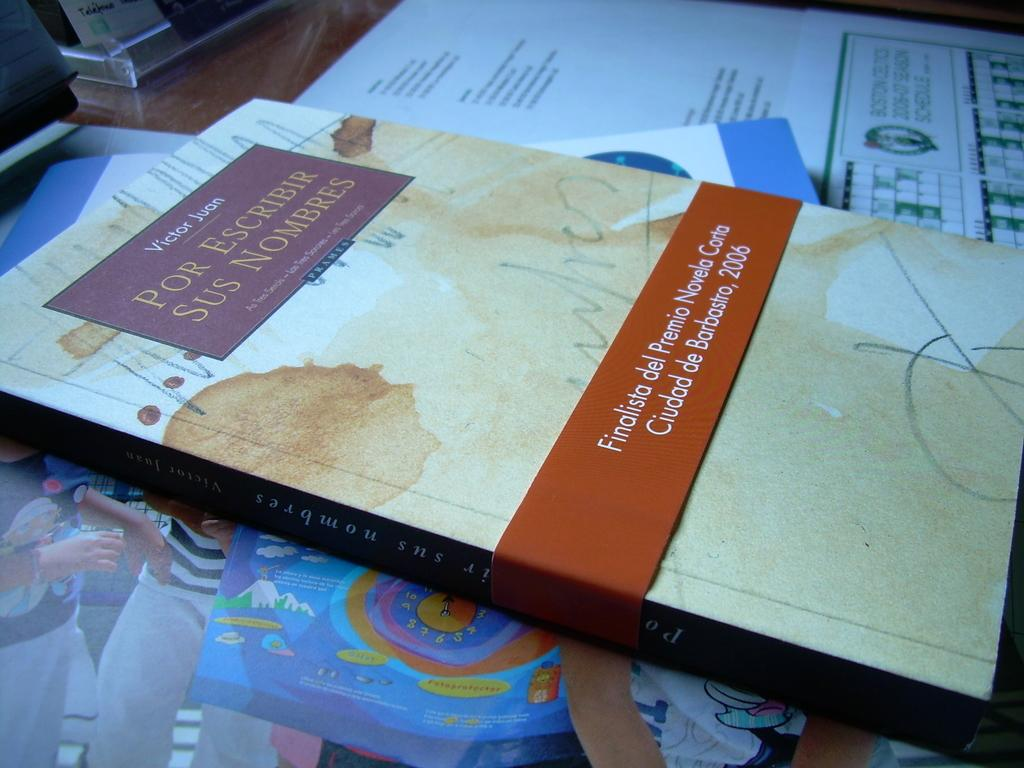<image>
Provide a brief description of the given image. Victor Juan is the author of "Por Escribir Sus Nombres". 